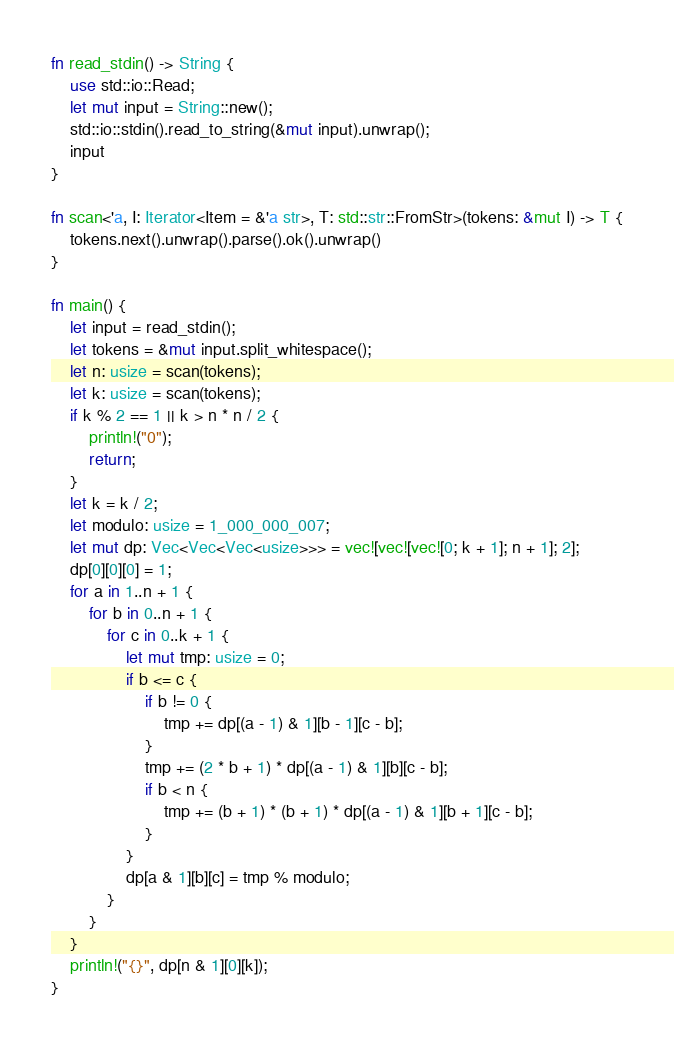Convert code to text. <code><loc_0><loc_0><loc_500><loc_500><_Rust_>fn read_stdin() -> String {
    use std::io::Read;
    let mut input = String::new();
    std::io::stdin().read_to_string(&mut input).unwrap();
    input
}

fn scan<'a, I: Iterator<Item = &'a str>, T: std::str::FromStr>(tokens: &mut I) -> T {
    tokens.next().unwrap().parse().ok().unwrap()
}

fn main() {
    let input = read_stdin();
    let tokens = &mut input.split_whitespace();
    let n: usize = scan(tokens);
    let k: usize = scan(tokens);
    if k % 2 == 1 || k > n * n / 2 {
        println!("0");
        return;
    }
    let k = k / 2;
    let modulo: usize = 1_000_000_007;
    let mut dp: Vec<Vec<Vec<usize>>> = vec![vec![vec![0; k + 1]; n + 1]; 2];
    dp[0][0][0] = 1;
    for a in 1..n + 1 {
        for b in 0..n + 1 {
            for c in 0..k + 1 {
                let mut tmp: usize = 0;
                if b <= c {
                    if b != 0 {
                        tmp += dp[(a - 1) & 1][b - 1][c - b];
                    }
                    tmp += (2 * b + 1) * dp[(a - 1) & 1][b][c - b];
                    if b < n {
                        tmp += (b + 1) * (b + 1) * dp[(a - 1) & 1][b + 1][c - b];
                    }
                }
                dp[a & 1][b][c] = tmp % modulo;
            }
        }
    }
    println!("{}", dp[n & 1][0][k]);
}
</code> 